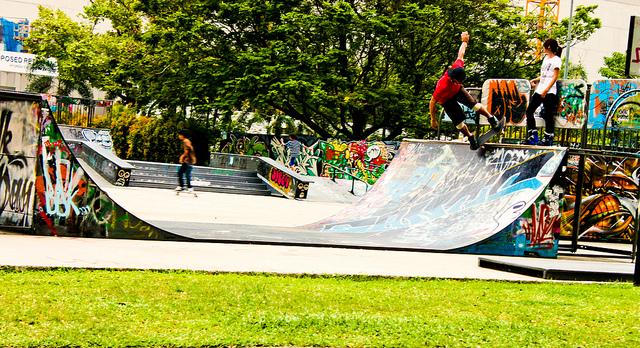How has the park been decorated?
Keep it brief. Yes. Is that a large half pipe?
Answer briefly. Yes. Is this a co-ed sport?
Keep it brief. Yes. 